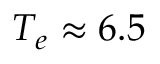Convert formula to latex. <formula><loc_0><loc_0><loc_500><loc_500>T _ { e } \approx 6 . 5</formula> 